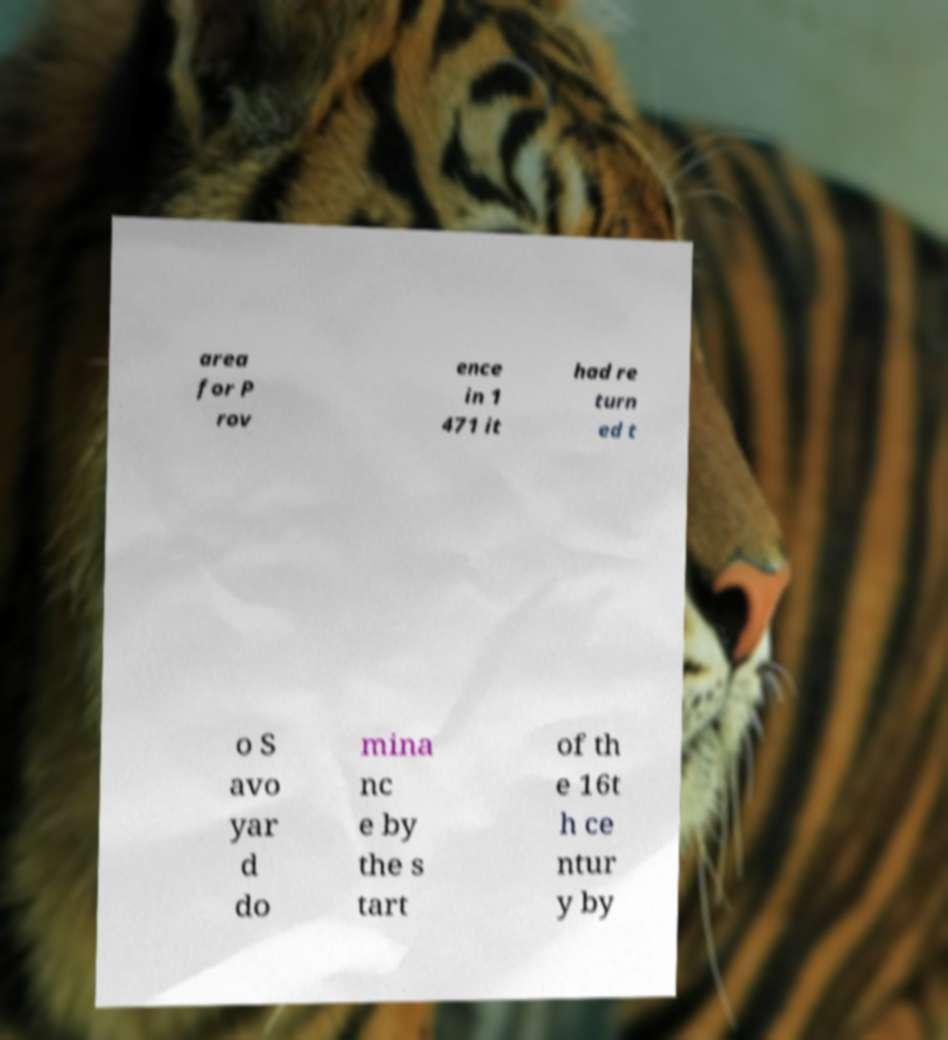There's text embedded in this image that I need extracted. Can you transcribe it verbatim? area for P rov ence in 1 471 it had re turn ed t o S avo yar d do mina nc e by the s tart of th e 16t h ce ntur y by 